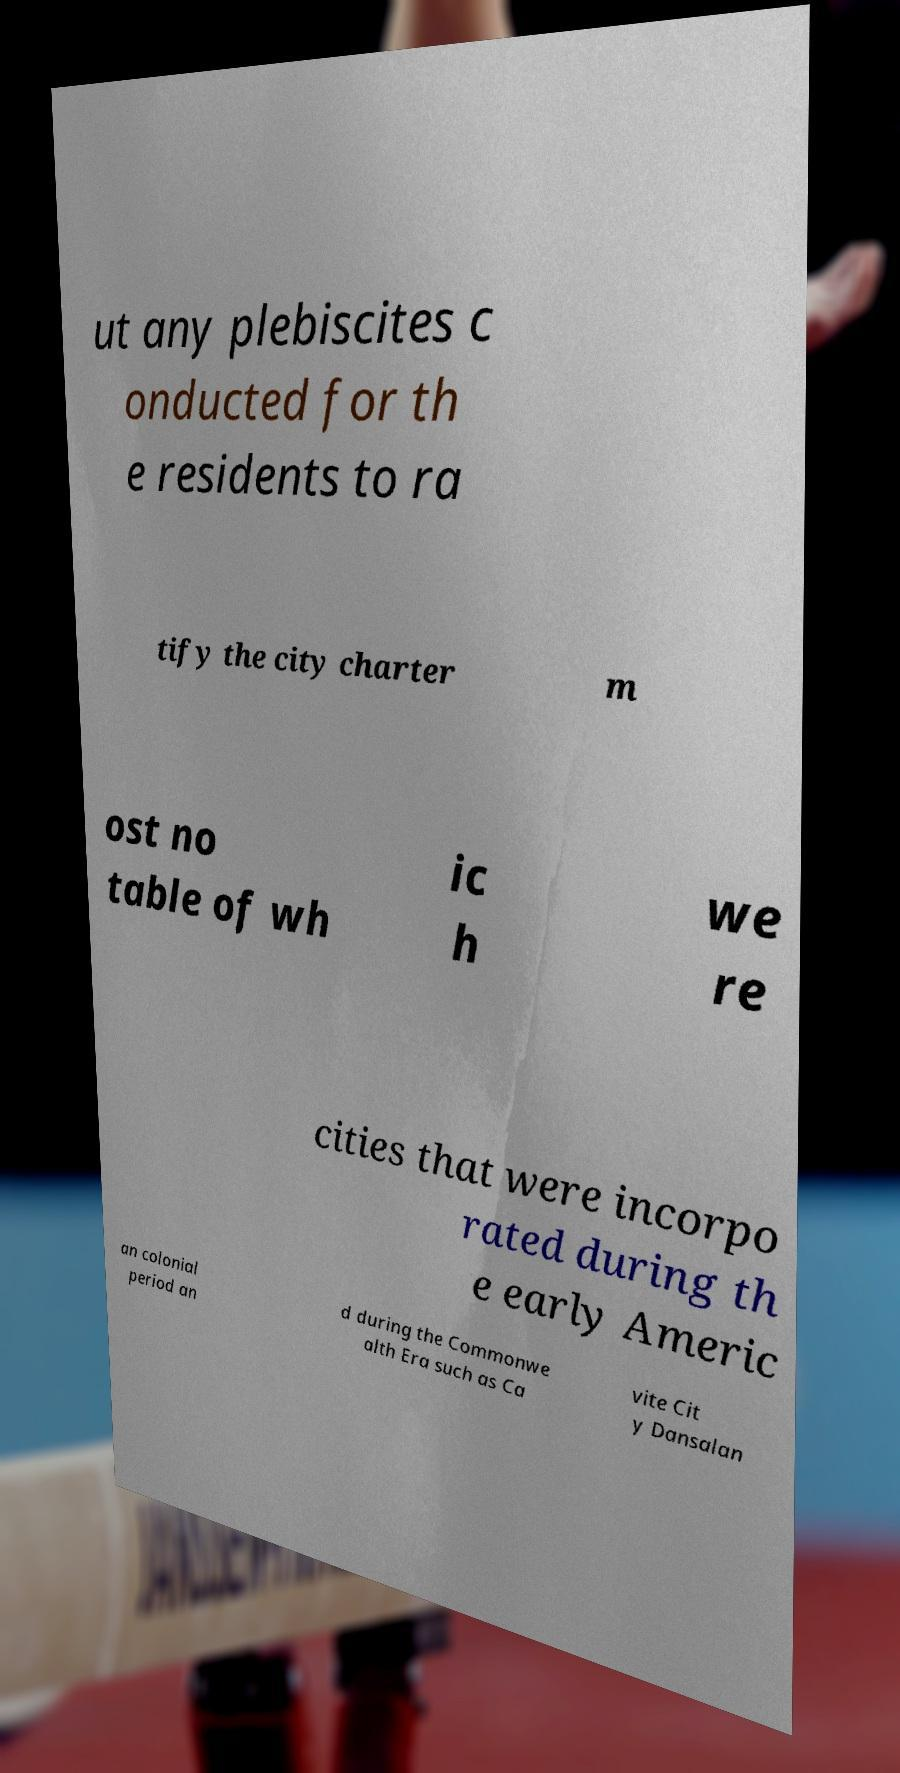Could you assist in decoding the text presented in this image and type it out clearly? ut any plebiscites c onducted for th e residents to ra tify the city charter m ost no table of wh ic h we re cities that were incorpo rated during th e early Americ an colonial period an d during the Commonwe alth Era such as Ca vite Cit y Dansalan 